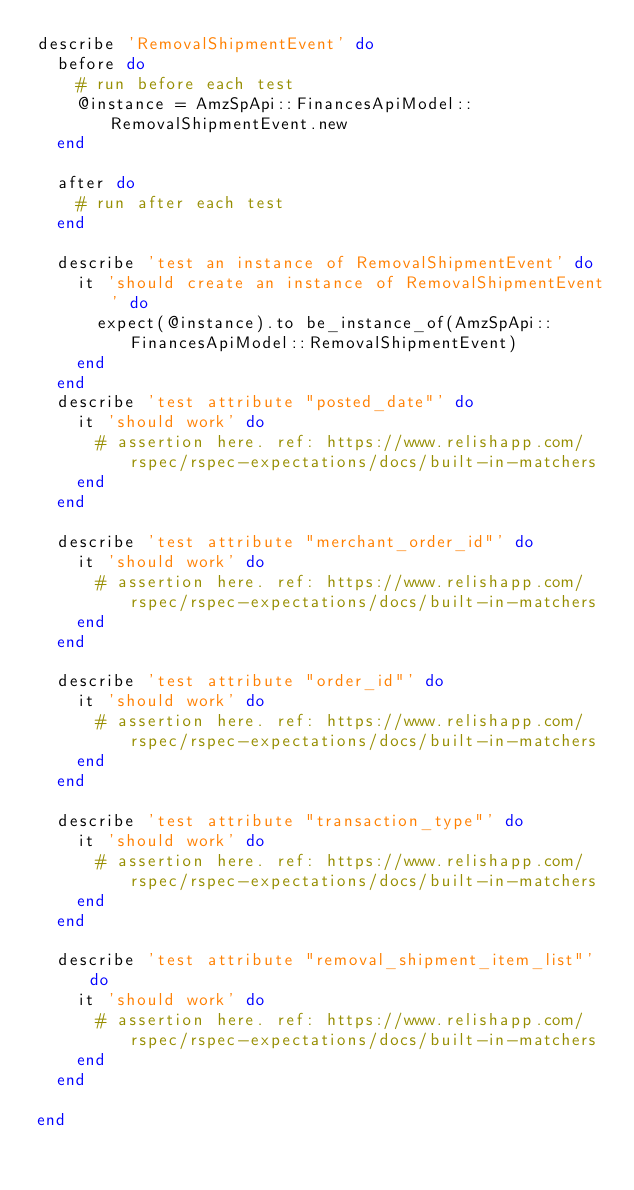Convert code to text. <code><loc_0><loc_0><loc_500><loc_500><_Ruby_>describe 'RemovalShipmentEvent' do
  before do
    # run before each test
    @instance = AmzSpApi::FinancesApiModel::RemovalShipmentEvent.new
  end

  after do
    # run after each test
  end

  describe 'test an instance of RemovalShipmentEvent' do
    it 'should create an instance of RemovalShipmentEvent' do
      expect(@instance).to be_instance_of(AmzSpApi::FinancesApiModel::RemovalShipmentEvent)
    end
  end
  describe 'test attribute "posted_date"' do
    it 'should work' do
      # assertion here. ref: https://www.relishapp.com/rspec/rspec-expectations/docs/built-in-matchers
    end
  end

  describe 'test attribute "merchant_order_id"' do
    it 'should work' do
      # assertion here. ref: https://www.relishapp.com/rspec/rspec-expectations/docs/built-in-matchers
    end
  end

  describe 'test attribute "order_id"' do
    it 'should work' do
      # assertion here. ref: https://www.relishapp.com/rspec/rspec-expectations/docs/built-in-matchers
    end
  end

  describe 'test attribute "transaction_type"' do
    it 'should work' do
      # assertion here. ref: https://www.relishapp.com/rspec/rspec-expectations/docs/built-in-matchers
    end
  end

  describe 'test attribute "removal_shipment_item_list"' do
    it 'should work' do
      # assertion here. ref: https://www.relishapp.com/rspec/rspec-expectations/docs/built-in-matchers
    end
  end

end
</code> 